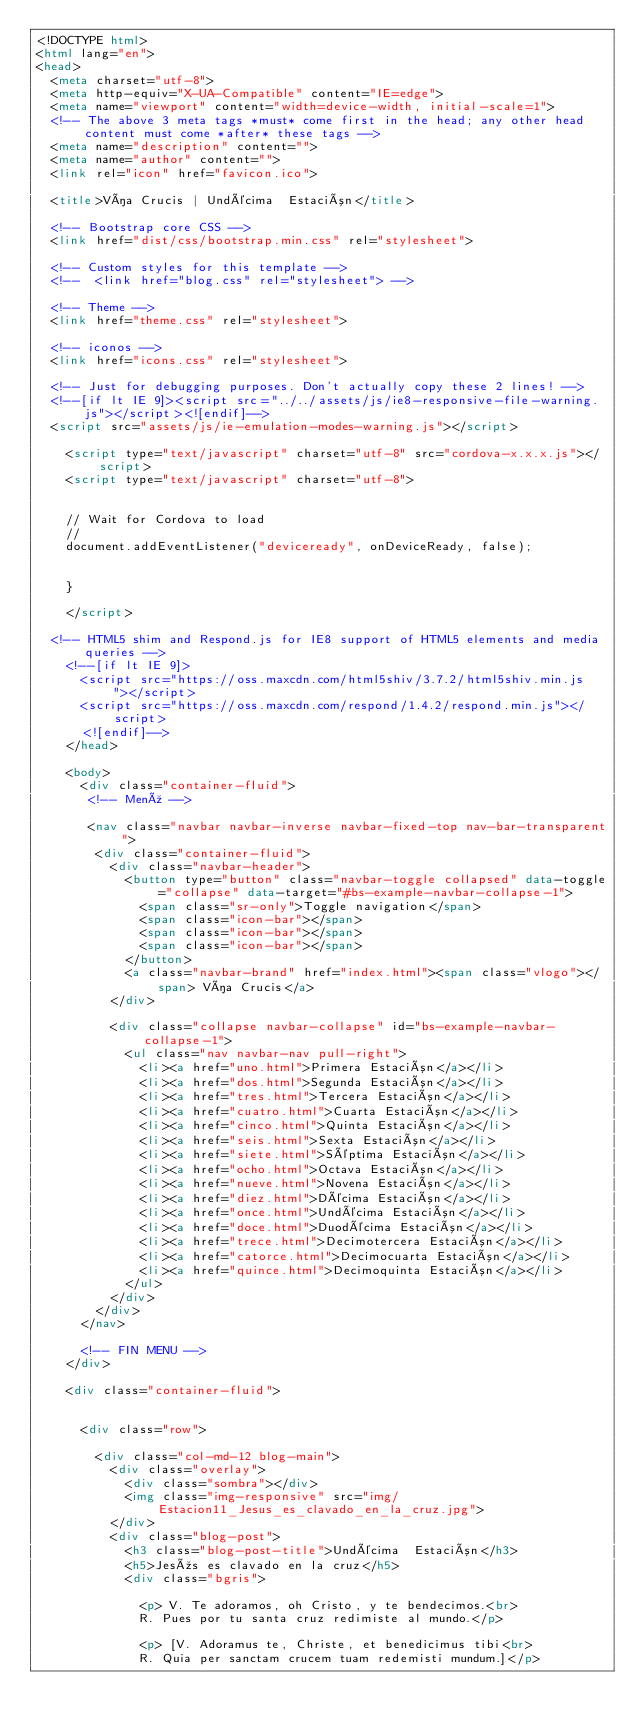Convert code to text. <code><loc_0><loc_0><loc_500><loc_500><_HTML_><!DOCTYPE html>
<html lang="en">
<head>
  <meta charset="utf-8">
  <meta http-equiv="X-UA-Compatible" content="IE=edge">
  <meta name="viewport" content="width=device-width, initial-scale=1">
  <!-- The above 3 meta tags *must* come first in the head; any other head content must come *after* these tags -->
  <meta name="description" content="">
  <meta name="author" content="">
  <link rel="icon" href="favicon.ico">

  <title>Vía Crucis | Undécima  Estación</title>

  <!-- Bootstrap core CSS -->
  <link href="dist/css/bootstrap.min.css" rel="stylesheet">

  <!-- Custom styles for this template -->
  <!--  <link href="blog.css" rel="stylesheet"> -->

  <!-- Theme -->
  <link href="theme.css" rel="stylesheet">

  <!-- iconos -->
  <link href="icons.css" rel="stylesheet">

  <!-- Just for debugging purposes. Don't actually copy these 2 lines! -->
  <!--[if lt IE 9]><script src="../../assets/js/ie8-responsive-file-warning.js"></script><![endif]-->
  <script src="assets/js/ie-emulation-modes-warning.js"></script>

    <script type="text/javascript" charset="utf-8" src="cordova-x.x.x.js"></script>
    <script type="text/javascript" charset="utf-8">


    // Wait for Cordova to load
    //
    document.addEventListener("deviceready", onDeviceReady, false);

   
    }

    </script>

  <!-- HTML5 shim and Respond.js for IE8 support of HTML5 elements and media queries -->
    <!--[if lt IE 9]>
      <script src="https://oss.maxcdn.com/html5shiv/3.7.2/html5shiv.min.js"></script>
      <script src="https://oss.maxcdn.com/respond/1.4.2/respond.min.js"></script>
      <![endif]-->
    </head>

    <body>
      <div class="container-fluid">
       <!-- Menú -->

       <nav class="navbar navbar-inverse navbar-fixed-top nav-bar-transparent">
        <div class="container-fluid">
          <div class="navbar-header">
            <button type="button" class="navbar-toggle collapsed" data-toggle="collapse" data-target="#bs-example-navbar-collapse-1">
              <span class="sr-only">Toggle navigation</span>
              <span class="icon-bar"></span>
              <span class="icon-bar"></span>
              <span class="icon-bar"></span>
            </button>
            <a class="navbar-brand" href="index.html"><span class="vlogo"></span> Vía Crucis</a>
          </div>

          <div class="collapse navbar-collapse" id="bs-example-navbar-collapse-1">
            <ul class="nav navbar-nav pull-right">
              <li><a href="uno.html">Primera Estación</a></li>
              <li><a href="dos.html">Segunda Estación</a></li>
              <li><a href="tres.html">Tercera Estación</a></li>
              <li><a href="cuatro.html">Cuarta Estación</a></li>
              <li><a href="cinco.html">Quinta Estación</a></li>
              <li><a href="seis.html">Sexta Estación</a></li>
              <li><a href="siete.html">Séptima Estación</a></li>
              <li><a href="ocho.html">Octava Estación</a></li>
              <li><a href="nueve.html">Novena Estación</a></li>
              <li><a href="diez.html">Décima Estación</a></li>
              <li><a href="once.html">Undécima Estación</a></li>
              <li><a href="doce.html">Duodécima Estación</a></li>
              <li><a href="trece.html">Decimotercera Estación</a></li>
              <li><a href="catorce.html">Decimocuarta Estación</a></li>
              <li><a href="quince.html">Decimoquinta Estación</a></li>
            </ul>
          </div>
        </div>
      </nav>

      <!-- FIN MENU -->
    </div>

    <div class="container-fluid">


      <div class="row">

        <div class="col-md-12 blog-main">
          <div class="overlay">
            <div class="sombra"></div>
            <img class="img-responsive" src="img/Estacion11_Jesus_es_clavado_en_la_cruz.jpg">
          </div>
          <div class="blog-post">
            <h3 class="blog-post-title">Undécima  Estación</h3>
            <h5>Jesús es clavado en la cruz</h5>
            <div class="bgris">

              <p> V. Te adoramos, oh Cristo, y te bendecimos.<br>
              R. Pues por tu santa cruz redimiste al mundo.</p>

              <p> [V. Adoramus te, Christe, et benedicimus tibi<br>
              R. Quia per sanctam crucem tuam redemisti mundum.]</p>
</code> 